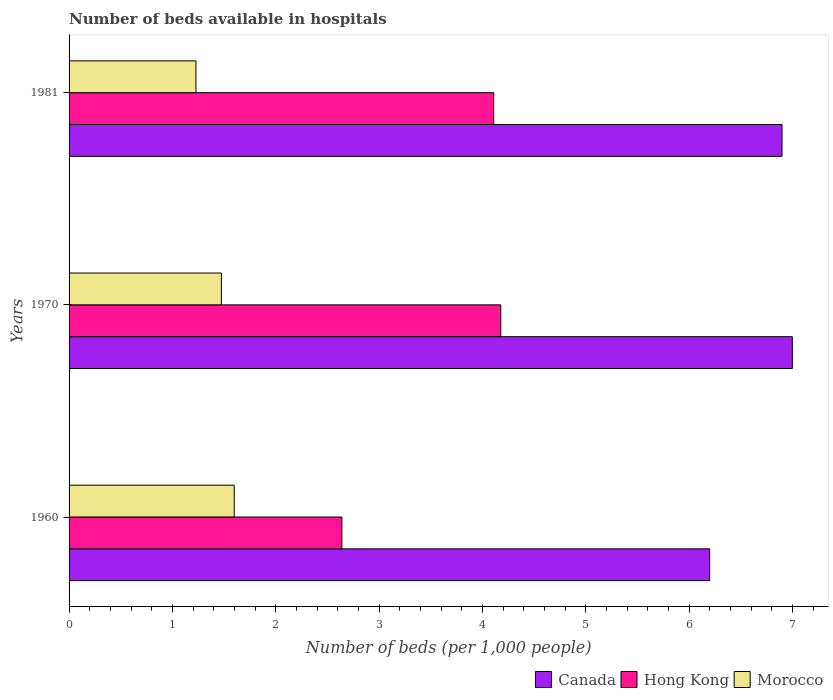Are the number of bars on each tick of the Y-axis equal?
Ensure brevity in your answer.  Yes. What is the label of the 2nd group of bars from the top?
Provide a succinct answer. 1970. What is the number of beds in the hospiatls of in Canada in 1981?
Offer a very short reply. 6.9. Across all years, what is the maximum number of beds in the hospiatls of in Canada?
Provide a short and direct response. 7. Across all years, what is the minimum number of beds in the hospiatls of in Canada?
Keep it short and to the point. 6.2. What is the total number of beds in the hospiatls of in Hong Kong in the graph?
Offer a very short reply. 10.93. What is the difference between the number of beds in the hospiatls of in Morocco in 1960 and that in 1970?
Your answer should be compact. 0.12. What is the difference between the number of beds in the hospiatls of in Canada in 1981 and the number of beds in the hospiatls of in Hong Kong in 1960?
Keep it short and to the point. 4.26. What is the average number of beds in the hospiatls of in Hong Kong per year?
Offer a very short reply. 3.64. In the year 1960, what is the difference between the number of beds in the hospiatls of in Morocco and number of beds in the hospiatls of in Hong Kong?
Ensure brevity in your answer.  -1.04. What is the ratio of the number of beds in the hospiatls of in Morocco in 1970 to that in 1981?
Offer a terse response. 1.2. Is the number of beds in the hospiatls of in Hong Kong in 1970 less than that in 1981?
Give a very brief answer. No. What is the difference between the highest and the second highest number of beds in the hospiatls of in Canada?
Your answer should be very brief. 0.1. What is the difference between the highest and the lowest number of beds in the hospiatls of in Hong Kong?
Keep it short and to the point. 1.54. In how many years, is the number of beds in the hospiatls of in Morocco greater than the average number of beds in the hospiatls of in Morocco taken over all years?
Your answer should be compact. 2. What does the 2nd bar from the top in 1960 represents?
Your answer should be very brief. Hong Kong. What does the 2nd bar from the bottom in 1970 represents?
Offer a very short reply. Hong Kong. Is it the case that in every year, the sum of the number of beds in the hospiatls of in Hong Kong and number of beds in the hospiatls of in Canada is greater than the number of beds in the hospiatls of in Morocco?
Offer a terse response. Yes. Are all the bars in the graph horizontal?
Your answer should be very brief. Yes. Does the graph contain any zero values?
Ensure brevity in your answer.  No. Does the graph contain grids?
Offer a very short reply. No. How many legend labels are there?
Offer a terse response. 3. What is the title of the graph?
Provide a short and direct response. Number of beds available in hospitals. Does "Colombia" appear as one of the legend labels in the graph?
Your answer should be very brief. No. What is the label or title of the X-axis?
Offer a terse response. Number of beds (per 1,0 people). What is the Number of beds (per 1,000 people) in Canada in 1960?
Ensure brevity in your answer.  6.2. What is the Number of beds (per 1,000 people) in Hong Kong in 1960?
Your response must be concise. 2.64. What is the Number of beds (per 1,000 people) in Morocco in 1960?
Your answer should be very brief. 1.6. What is the Number of beds (per 1,000 people) in Canada in 1970?
Keep it short and to the point. 7. What is the Number of beds (per 1,000 people) in Hong Kong in 1970?
Your response must be concise. 4.18. What is the Number of beds (per 1,000 people) in Morocco in 1970?
Your answer should be compact. 1.47. What is the Number of beds (per 1,000 people) of Canada in 1981?
Keep it short and to the point. 6.9. What is the Number of beds (per 1,000 people) of Hong Kong in 1981?
Give a very brief answer. 4.11. What is the Number of beds (per 1,000 people) of Morocco in 1981?
Ensure brevity in your answer.  1.23. Across all years, what is the maximum Number of beds (per 1,000 people) of Hong Kong?
Provide a succinct answer. 4.18. Across all years, what is the maximum Number of beds (per 1,000 people) in Morocco?
Keep it short and to the point. 1.6. Across all years, what is the minimum Number of beds (per 1,000 people) in Canada?
Your answer should be very brief. 6.2. Across all years, what is the minimum Number of beds (per 1,000 people) of Hong Kong?
Your response must be concise. 2.64. Across all years, what is the minimum Number of beds (per 1,000 people) in Morocco?
Ensure brevity in your answer.  1.23. What is the total Number of beds (per 1,000 people) of Canada in the graph?
Ensure brevity in your answer.  20.1. What is the total Number of beds (per 1,000 people) in Hong Kong in the graph?
Ensure brevity in your answer.  10.93. What is the total Number of beds (per 1,000 people) in Morocco in the graph?
Your answer should be compact. 4.3. What is the difference between the Number of beds (per 1,000 people) in Canada in 1960 and that in 1970?
Make the answer very short. -0.8. What is the difference between the Number of beds (per 1,000 people) of Hong Kong in 1960 and that in 1970?
Provide a short and direct response. -1.54. What is the difference between the Number of beds (per 1,000 people) in Morocco in 1960 and that in 1970?
Your response must be concise. 0.12. What is the difference between the Number of beds (per 1,000 people) in Hong Kong in 1960 and that in 1981?
Give a very brief answer. -1.47. What is the difference between the Number of beds (per 1,000 people) of Morocco in 1960 and that in 1981?
Offer a terse response. 0.37. What is the difference between the Number of beds (per 1,000 people) of Hong Kong in 1970 and that in 1981?
Keep it short and to the point. 0.07. What is the difference between the Number of beds (per 1,000 people) in Morocco in 1970 and that in 1981?
Provide a succinct answer. 0.25. What is the difference between the Number of beds (per 1,000 people) of Canada in 1960 and the Number of beds (per 1,000 people) of Hong Kong in 1970?
Offer a terse response. 2.02. What is the difference between the Number of beds (per 1,000 people) of Canada in 1960 and the Number of beds (per 1,000 people) of Morocco in 1970?
Your answer should be compact. 4.73. What is the difference between the Number of beds (per 1,000 people) of Hong Kong in 1960 and the Number of beds (per 1,000 people) of Morocco in 1970?
Make the answer very short. 1.17. What is the difference between the Number of beds (per 1,000 people) of Canada in 1960 and the Number of beds (per 1,000 people) of Hong Kong in 1981?
Ensure brevity in your answer.  2.09. What is the difference between the Number of beds (per 1,000 people) of Canada in 1960 and the Number of beds (per 1,000 people) of Morocco in 1981?
Offer a very short reply. 4.97. What is the difference between the Number of beds (per 1,000 people) in Hong Kong in 1960 and the Number of beds (per 1,000 people) in Morocco in 1981?
Provide a short and direct response. 1.41. What is the difference between the Number of beds (per 1,000 people) of Canada in 1970 and the Number of beds (per 1,000 people) of Hong Kong in 1981?
Offer a very short reply. 2.89. What is the difference between the Number of beds (per 1,000 people) in Canada in 1970 and the Number of beds (per 1,000 people) in Morocco in 1981?
Your response must be concise. 5.77. What is the difference between the Number of beds (per 1,000 people) in Hong Kong in 1970 and the Number of beds (per 1,000 people) in Morocco in 1981?
Provide a short and direct response. 2.95. What is the average Number of beds (per 1,000 people) in Hong Kong per year?
Provide a succinct answer. 3.64. What is the average Number of beds (per 1,000 people) in Morocco per year?
Your answer should be very brief. 1.43. In the year 1960, what is the difference between the Number of beds (per 1,000 people) of Canada and Number of beds (per 1,000 people) of Hong Kong?
Provide a succinct answer. 3.56. In the year 1960, what is the difference between the Number of beds (per 1,000 people) of Canada and Number of beds (per 1,000 people) of Morocco?
Provide a short and direct response. 4.6. In the year 1960, what is the difference between the Number of beds (per 1,000 people) in Hong Kong and Number of beds (per 1,000 people) in Morocco?
Ensure brevity in your answer.  1.04. In the year 1970, what is the difference between the Number of beds (per 1,000 people) of Canada and Number of beds (per 1,000 people) of Hong Kong?
Keep it short and to the point. 2.82. In the year 1970, what is the difference between the Number of beds (per 1,000 people) in Canada and Number of beds (per 1,000 people) in Morocco?
Provide a short and direct response. 5.53. In the year 1970, what is the difference between the Number of beds (per 1,000 people) in Hong Kong and Number of beds (per 1,000 people) in Morocco?
Ensure brevity in your answer.  2.7. In the year 1981, what is the difference between the Number of beds (per 1,000 people) in Canada and Number of beds (per 1,000 people) in Hong Kong?
Provide a succinct answer. 2.79. In the year 1981, what is the difference between the Number of beds (per 1,000 people) of Canada and Number of beds (per 1,000 people) of Morocco?
Provide a short and direct response. 5.67. In the year 1981, what is the difference between the Number of beds (per 1,000 people) of Hong Kong and Number of beds (per 1,000 people) of Morocco?
Your response must be concise. 2.88. What is the ratio of the Number of beds (per 1,000 people) of Canada in 1960 to that in 1970?
Your response must be concise. 0.89. What is the ratio of the Number of beds (per 1,000 people) of Hong Kong in 1960 to that in 1970?
Provide a short and direct response. 0.63. What is the ratio of the Number of beds (per 1,000 people) in Morocco in 1960 to that in 1970?
Ensure brevity in your answer.  1.08. What is the ratio of the Number of beds (per 1,000 people) of Canada in 1960 to that in 1981?
Keep it short and to the point. 0.9. What is the ratio of the Number of beds (per 1,000 people) in Hong Kong in 1960 to that in 1981?
Provide a short and direct response. 0.64. What is the ratio of the Number of beds (per 1,000 people) in Morocco in 1960 to that in 1981?
Give a very brief answer. 1.3. What is the ratio of the Number of beds (per 1,000 people) of Canada in 1970 to that in 1981?
Offer a terse response. 1.01. What is the ratio of the Number of beds (per 1,000 people) in Hong Kong in 1970 to that in 1981?
Keep it short and to the point. 1.02. What is the ratio of the Number of beds (per 1,000 people) in Morocco in 1970 to that in 1981?
Make the answer very short. 1.2. What is the difference between the highest and the second highest Number of beds (per 1,000 people) of Canada?
Offer a very short reply. 0.1. What is the difference between the highest and the second highest Number of beds (per 1,000 people) of Hong Kong?
Your response must be concise. 0.07. What is the difference between the highest and the second highest Number of beds (per 1,000 people) in Morocco?
Offer a very short reply. 0.12. What is the difference between the highest and the lowest Number of beds (per 1,000 people) of Canada?
Your response must be concise. 0.8. What is the difference between the highest and the lowest Number of beds (per 1,000 people) of Hong Kong?
Offer a very short reply. 1.54. What is the difference between the highest and the lowest Number of beds (per 1,000 people) of Morocco?
Offer a terse response. 0.37. 